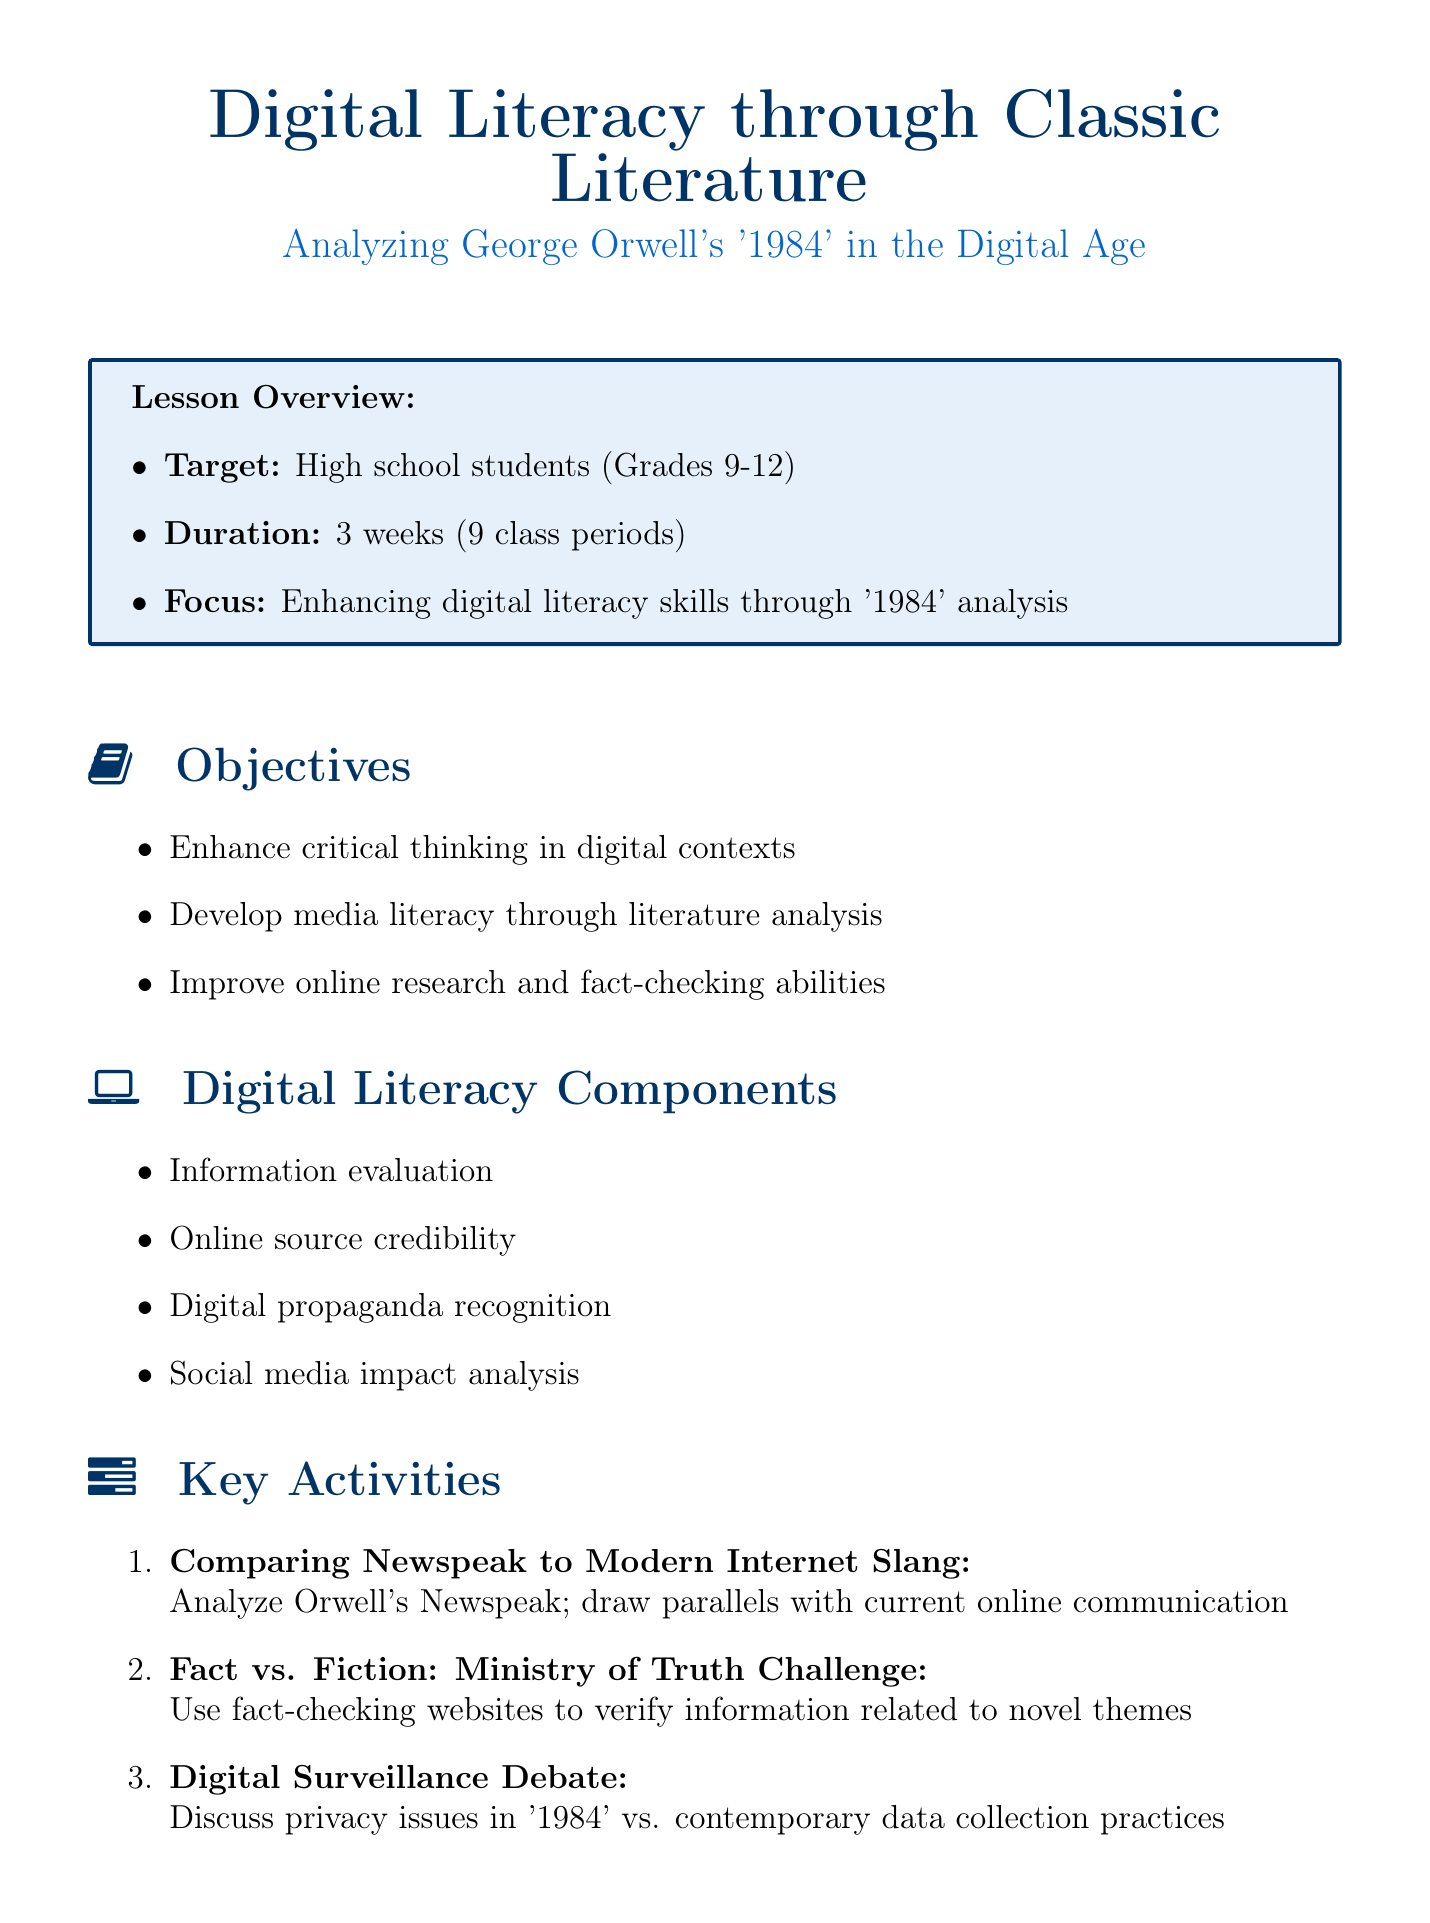What is the focus of the lesson plan? The focus is on enhancing digital literacy skills through the analysis of '1984'.
Answer: enhancing digital literacy skills through '1984' analysis How long is the duration of the lesson plan? The duration is specified as 3 weeks, encompassing 9 class periods.
Answer: 3 weeks (9 class periods) Who is the target audience for this lesson? The target audience is high school students, specifically grades 9-12.
Answer: high school students (Grades 9-12) What is one digital literacy component mentioned in the document? One component highlighted is online source credibility.
Answer: online source credibility What type of assessment is included in the lesson plan? The assessment is a digital essay that students will publish on Medium.com.
Answer: Digital Essay Which classic literature text is the focus of the analysis? The classic literature text focused on in the lesson plan is George Orwell's '1984'.
Answer: George Orwell's '1984' What is the name of the second key activity in the lesson plan? The second key activity is titled "Fact vs. Fiction: Ministry of Truth Challenge".
Answer: Fact vs. Fiction: Ministry of Truth Challenge Name a resource provided for the lesson plan. One resource provided is the electronic version of '1984' from Project Gutenberg.
Answer: Electronic version of '1984' (Project Gutenberg) What is one objective of the lesson plan? One objective is to improve online research and fact-checking abilities.
Answer: Improve online research and fact-checking abilities 